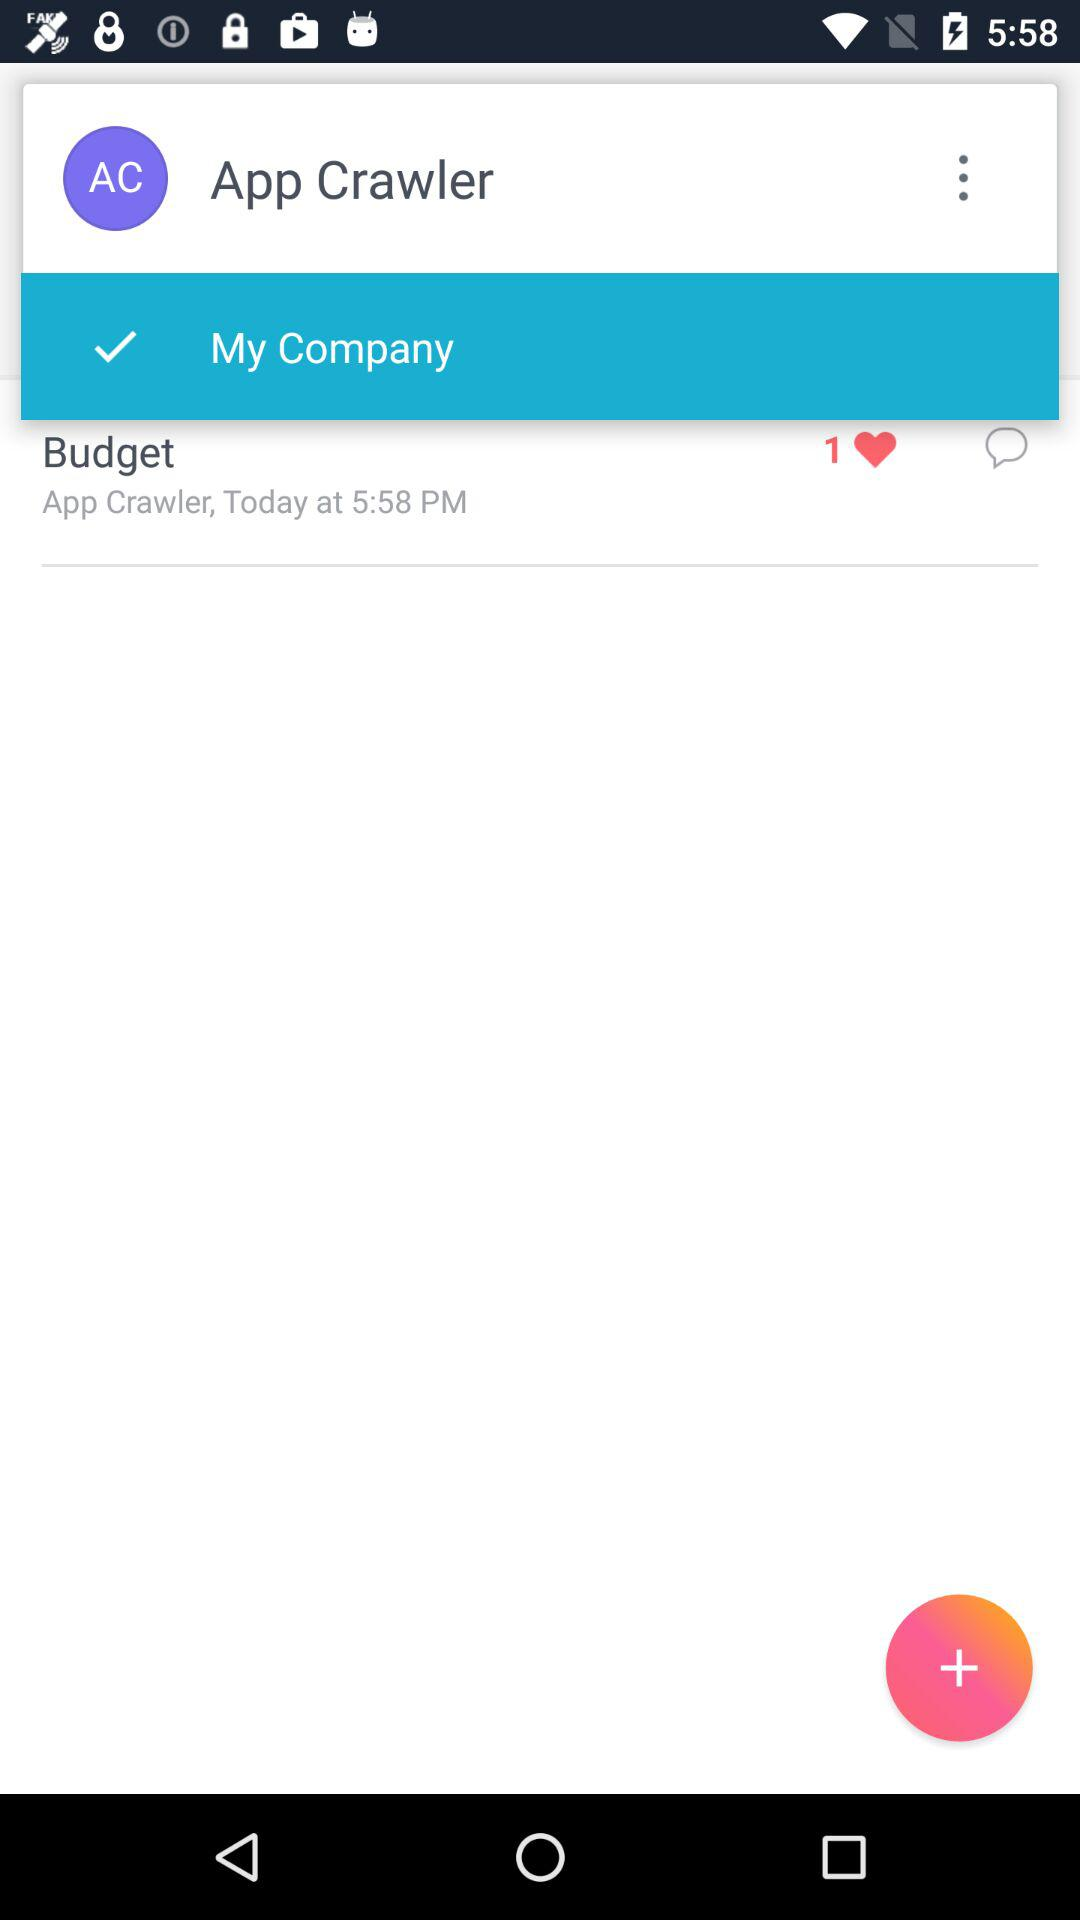What's the total number of likes of "Budget"? The total number of likes of "Budget" is 1. 